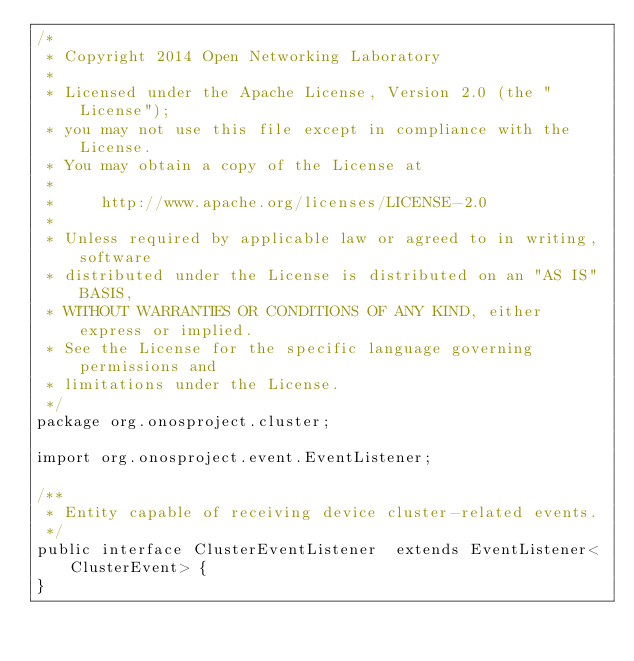<code> <loc_0><loc_0><loc_500><loc_500><_Java_>/*
 * Copyright 2014 Open Networking Laboratory
 *
 * Licensed under the Apache License, Version 2.0 (the "License");
 * you may not use this file except in compliance with the License.
 * You may obtain a copy of the License at
 *
 *     http://www.apache.org/licenses/LICENSE-2.0
 *
 * Unless required by applicable law or agreed to in writing, software
 * distributed under the License is distributed on an "AS IS" BASIS,
 * WITHOUT WARRANTIES OR CONDITIONS OF ANY KIND, either express or implied.
 * See the License for the specific language governing permissions and
 * limitations under the License.
 */
package org.onosproject.cluster;

import org.onosproject.event.EventListener;

/**
 * Entity capable of receiving device cluster-related events.
 */
public interface ClusterEventListener  extends EventListener<ClusterEvent> {
}
</code> 